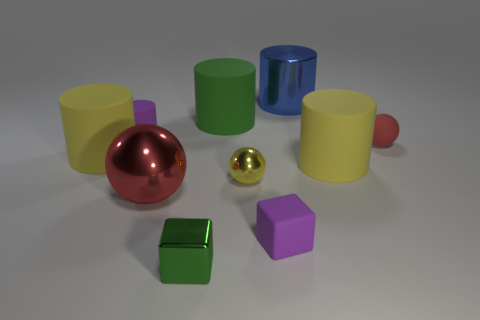What number of red objects are tiny metallic things or tiny objects?
Ensure brevity in your answer.  1. There is a cube that is the same material as the green cylinder; what is its color?
Your response must be concise. Purple. How many large objects are either gray metallic balls or yellow objects?
Offer a very short reply. 2. Are there fewer tiny purple matte cubes than cylinders?
Make the answer very short. Yes. What is the color of the big shiny object that is the same shape as the red matte object?
Your response must be concise. Red. Is there anything else that is the same shape as the tiny green metal thing?
Make the answer very short. Yes. Are there more yellow metallic objects than gray metallic cylinders?
Provide a short and direct response. Yes. How many other objects are the same material as the tiny red ball?
Offer a very short reply. 5. There is a big yellow thing that is on the right side of the yellow rubber cylinder that is left of the big matte thing that is right of the small purple block; what shape is it?
Offer a terse response. Cylinder. Are there fewer green cylinders that are to the left of the big red metal object than large blue metallic things in front of the small yellow sphere?
Provide a succinct answer. No. 